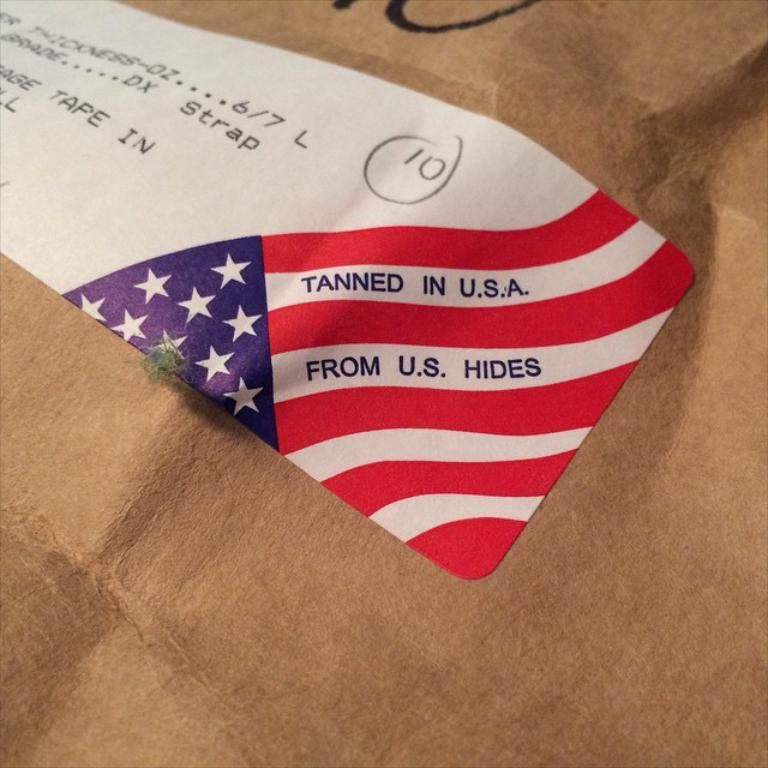<image>
Summarize the visual content of the image. A label stuck to a package claims that the contents were tanned in the usa. 